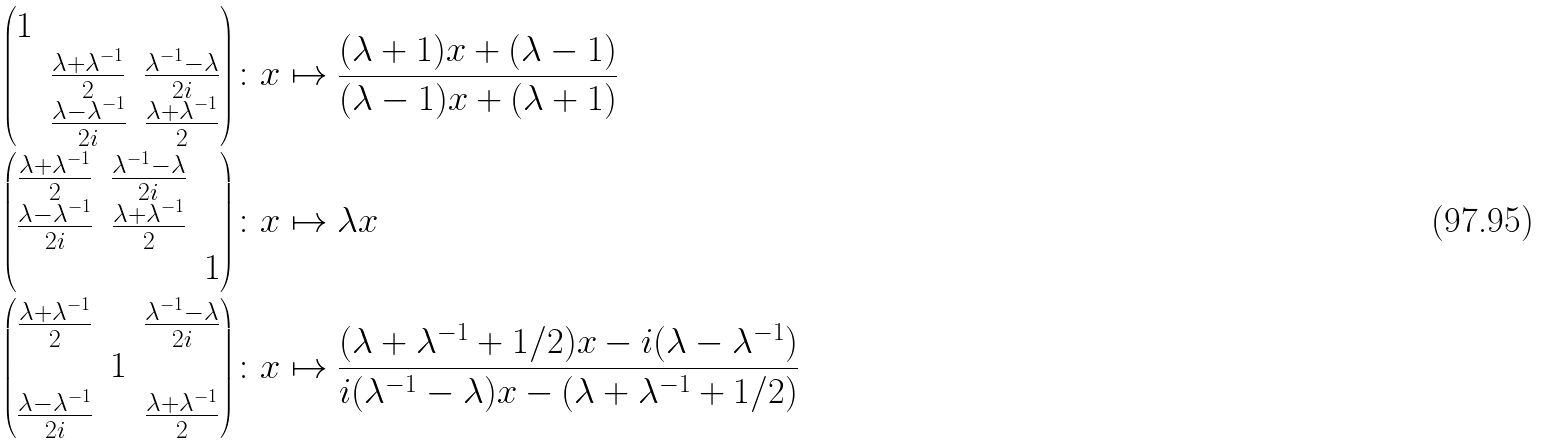Convert formula to latex. <formula><loc_0><loc_0><loc_500><loc_500>\left ( \begin{matrix} 1 & & \\ & \frac { \lambda + \lambda ^ { - 1 } } { 2 } & \frac { \lambda ^ { - 1 } - \lambda } { 2 i } \\ & \frac { \lambda - \lambda ^ { - 1 } } { 2 i } & \frac { \lambda + \lambda ^ { - 1 } } { 2 } \end{matrix} \right ) & \colon x \mapsto \frac { ( \lambda + 1 ) x + ( \lambda - 1 ) } { ( \lambda - 1 ) x + ( \lambda + 1 ) } \\ \left ( \begin{matrix} \frac { \lambda + \lambda ^ { - 1 } } { 2 } & \frac { \lambda ^ { - 1 } - \lambda } { 2 i } & \\ \frac { \lambda - \lambda ^ { - 1 } } { 2 i } & \frac { \lambda + \lambda ^ { - 1 } } { 2 } & \\ & & 1 \end{matrix} \right ) & \colon x \mapsto \lambda x \\ \left ( \begin{matrix} \frac { \lambda + \lambda ^ { - 1 } } { 2 } & & \frac { \lambda ^ { - 1 } - \lambda } { 2 i } \\ & 1 & \\ \frac { \lambda - \lambda ^ { - 1 } } { 2 i } & & \frac { \lambda + \lambda ^ { - 1 } } { 2 } \end{matrix} \right ) & \colon x \mapsto \frac { ( \lambda + \lambda ^ { - 1 } + 1 / 2 ) x - i ( \lambda - \lambda ^ { - 1 } ) } { i ( \lambda ^ { - 1 } - \lambda ) x - ( \lambda + \lambda ^ { - 1 } + 1 / 2 ) }</formula> 